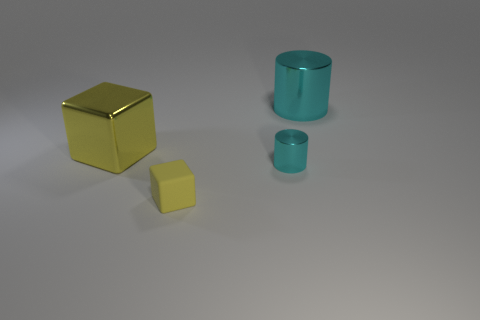There is a metallic cylinder that is behind the yellow object on the left side of the yellow rubber object; what color is it?
Ensure brevity in your answer.  Cyan. What number of other things are there of the same shape as the tiny rubber object?
Ensure brevity in your answer.  1. Is there a tiny ball made of the same material as the tiny yellow thing?
Your answer should be very brief. No. There is a cyan thing that is the same size as the yellow metal block; what is it made of?
Make the answer very short. Metal. The small thing that is left of the cyan thing that is in front of the cylinder behind the tiny shiny cylinder is what color?
Your response must be concise. Yellow. There is a yellow thing that is in front of the small shiny object; does it have the same shape as the big thing that is left of the tiny yellow thing?
Your answer should be very brief. Yes. How many tiny brown metallic balls are there?
Provide a short and direct response. 0. There is a metal cylinder that is the same size as the yellow rubber block; what color is it?
Your answer should be compact. Cyan. Does the cyan object that is in front of the yellow metallic block have the same material as the big thing to the right of the matte cube?
Give a very brief answer. Yes. What size is the metal object in front of the big shiny object that is on the left side of the large cyan cylinder?
Offer a terse response. Small. 